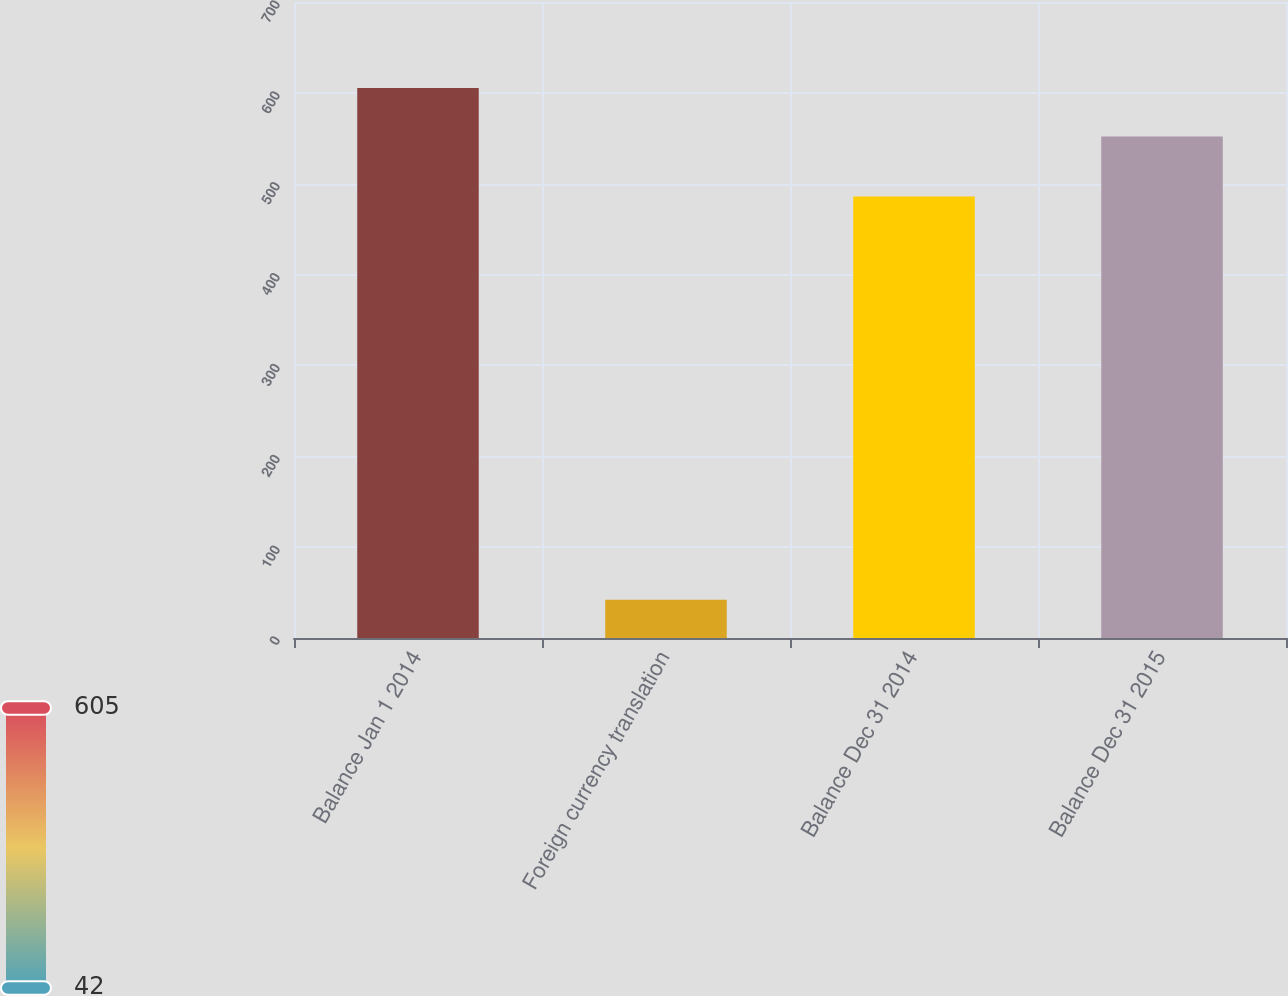<chart> <loc_0><loc_0><loc_500><loc_500><bar_chart><fcel>Balance Jan 1 2014<fcel>Foreign currency translation<fcel>Balance Dec 31 2014<fcel>Balance Dec 31 2015<nl><fcel>605.3<fcel>42<fcel>486<fcel>552<nl></chart> 